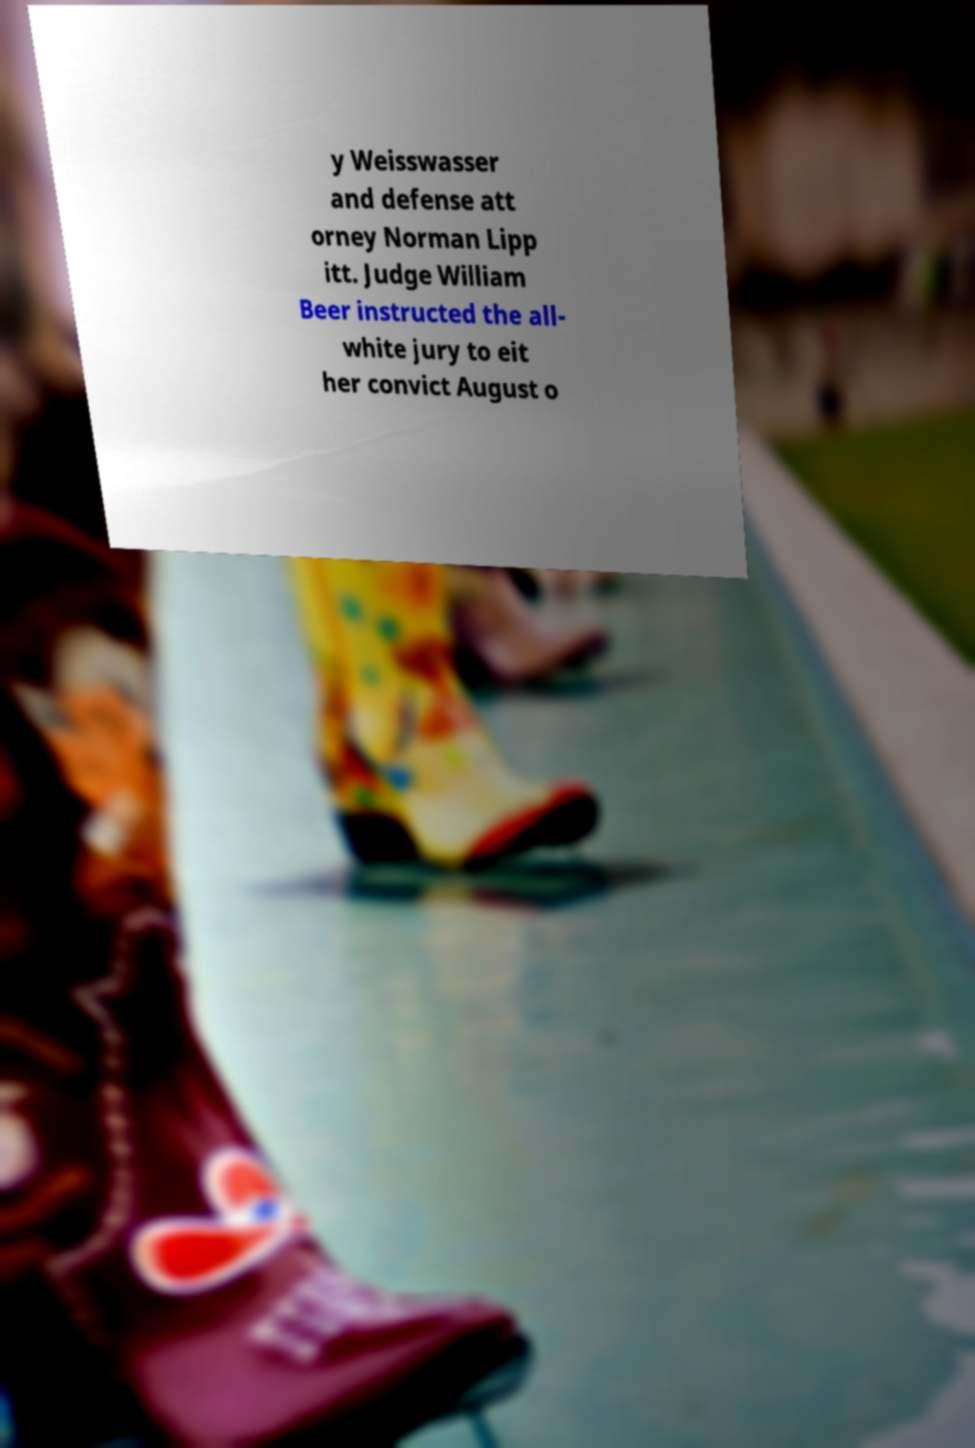Can you read and provide the text displayed in the image?This photo seems to have some interesting text. Can you extract and type it out for me? y Weisswasser and defense att orney Norman Lipp itt. Judge William Beer instructed the all- white jury to eit her convict August o 